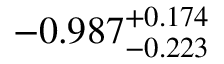<formula> <loc_0><loc_0><loc_500><loc_500>- 0 . 9 8 7 _ { - 0 . 2 2 3 } ^ { + 0 . 1 7 4 }</formula> 